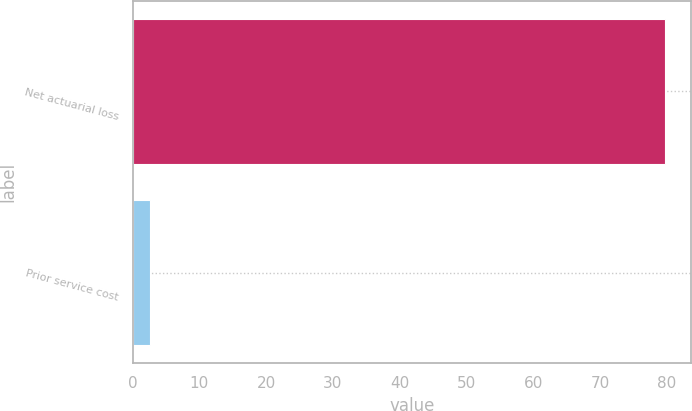Convert chart. <chart><loc_0><loc_0><loc_500><loc_500><bar_chart><fcel>Net actuarial loss<fcel>Prior service cost<nl><fcel>79.7<fcel>2.6<nl></chart> 